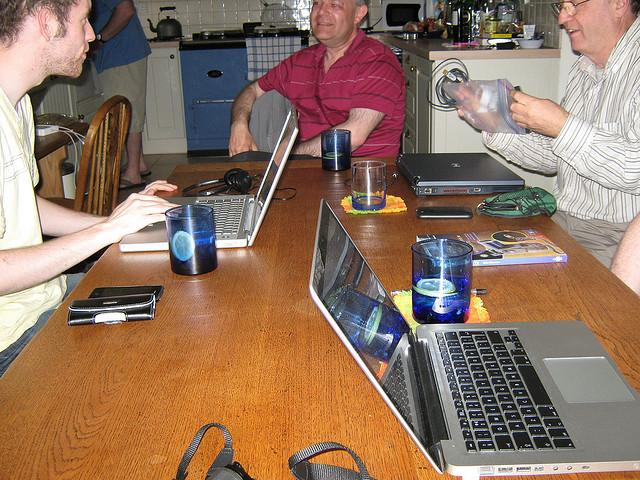Why is everyone at the table using laptops? working 